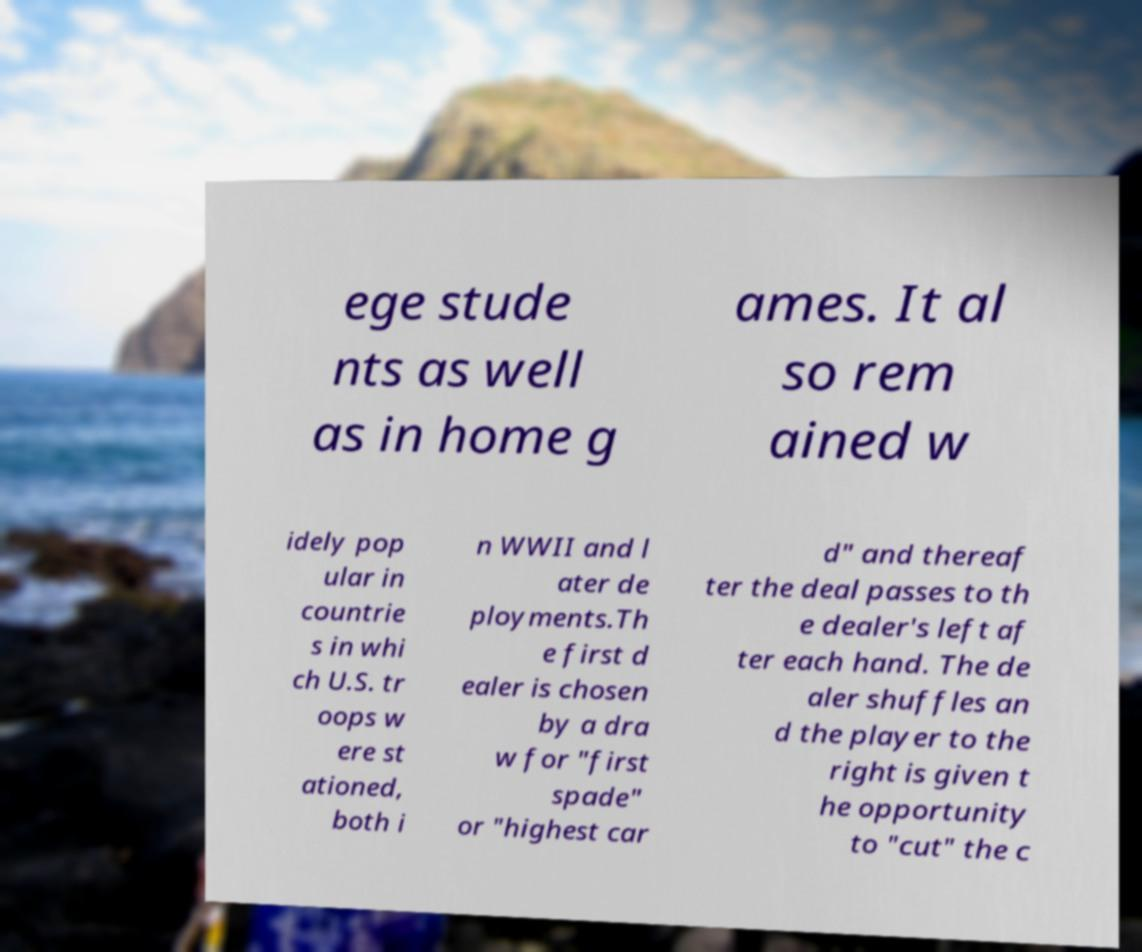Can you accurately transcribe the text from the provided image for me? ege stude nts as well as in home g ames. It al so rem ained w idely pop ular in countrie s in whi ch U.S. tr oops w ere st ationed, both i n WWII and l ater de ployments.Th e first d ealer is chosen by a dra w for "first spade" or "highest car d" and thereaf ter the deal passes to th e dealer's left af ter each hand. The de aler shuffles an d the player to the right is given t he opportunity to "cut" the c 